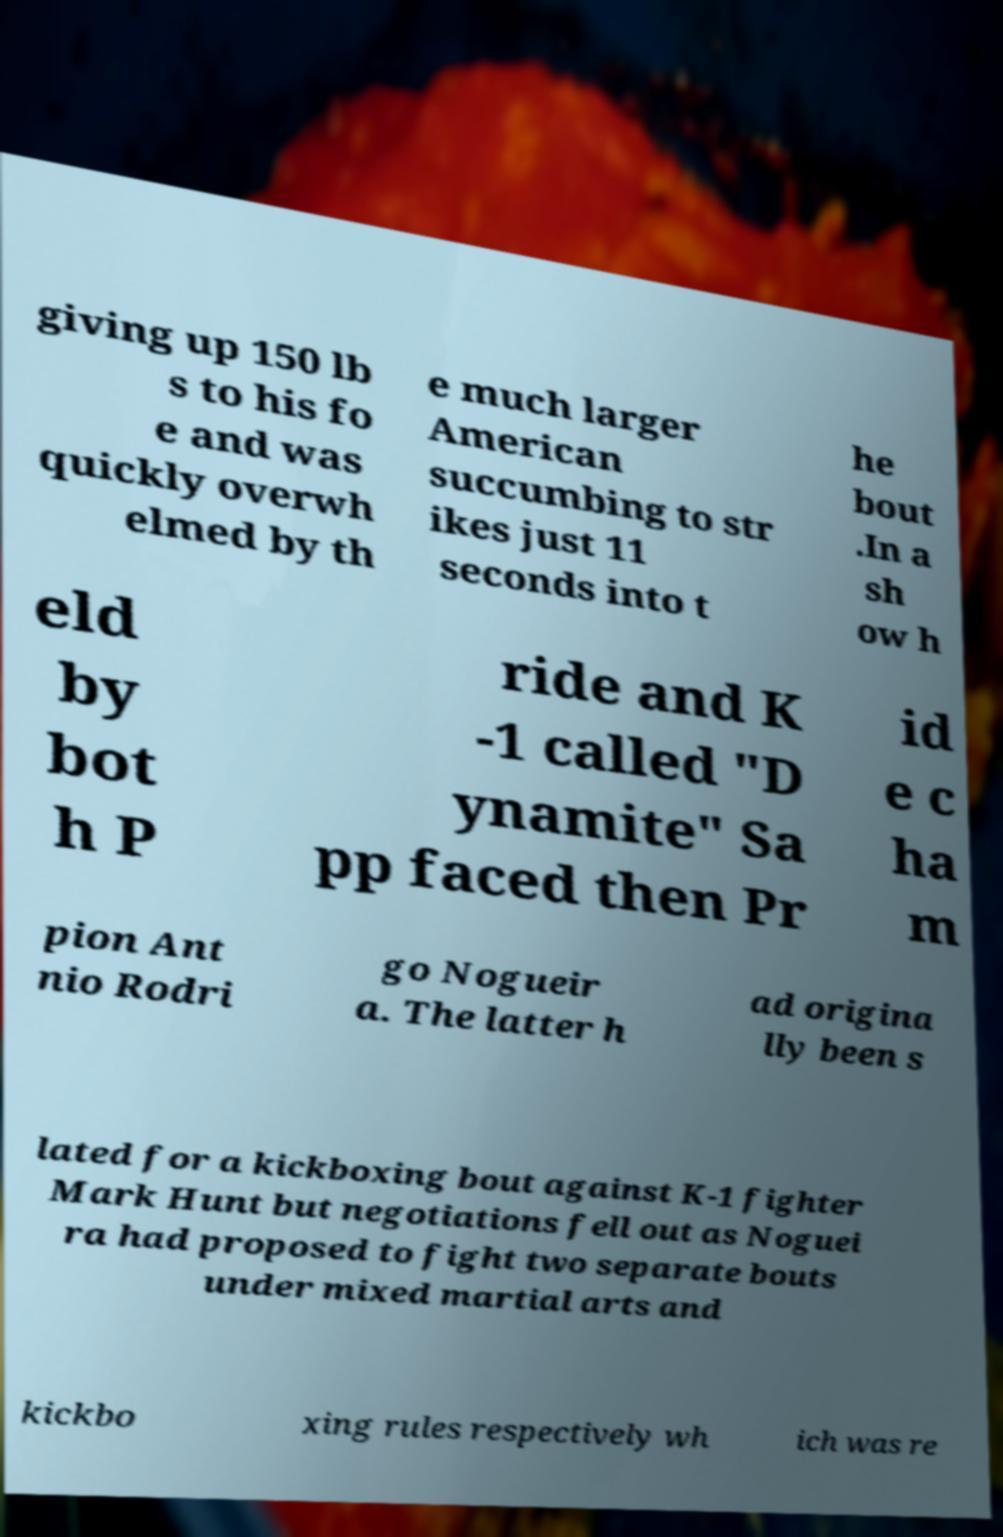Can you read and provide the text displayed in the image?This photo seems to have some interesting text. Can you extract and type it out for me? giving up 150 lb s to his fo e and was quickly overwh elmed by th e much larger American succumbing to str ikes just 11 seconds into t he bout .In a sh ow h eld by bot h P ride and K -1 called "D ynamite" Sa pp faced then Pr id e c ha m pion Ant nio Rodri go Nogueir a. The latter h ad origina lly been s lated for a kickboxing bout against K-1 fighter Mark Hunt but negotiations fell out as Noguei ra had proposed to fight two separate bouts under mixed martial arts and kickbo xing rules respectively wh ich was re 